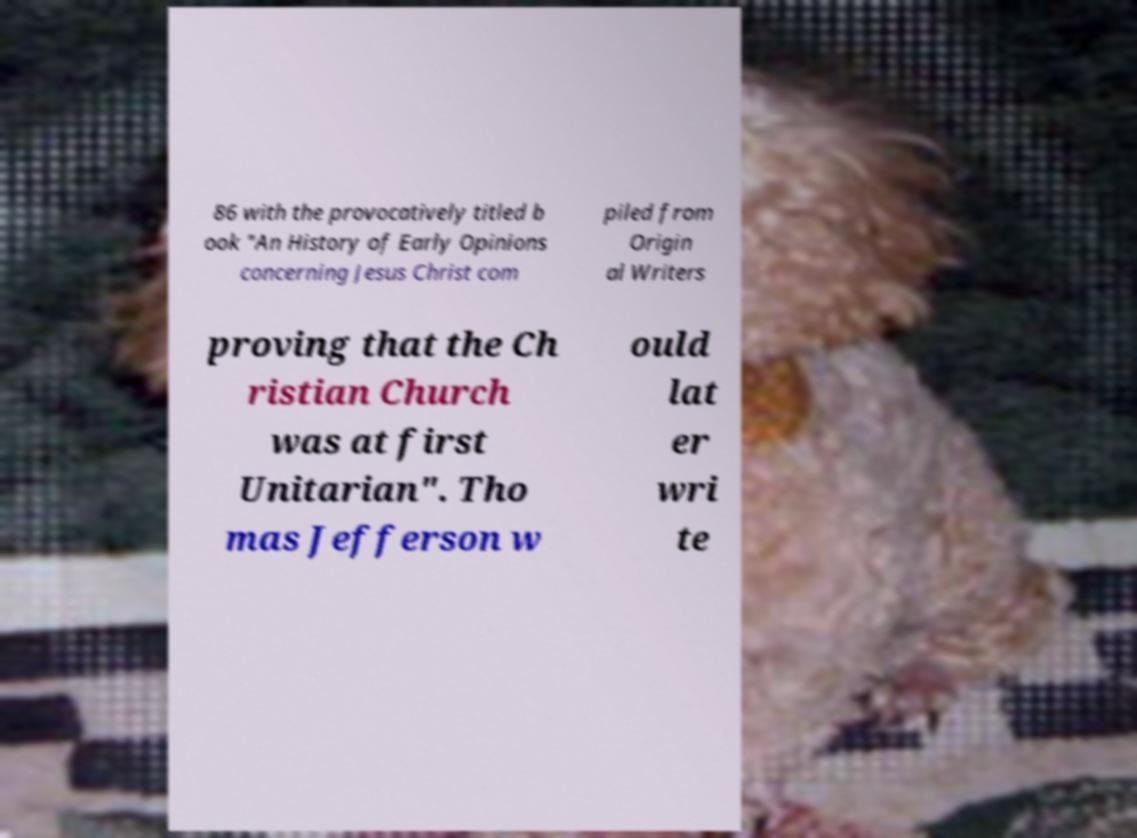Please read and relay the text visible in this image. What does it say? 86 with the provocatively titled b ook "An History of Early Opinions concerning Jesus Christ com piled from Origin al Writers proving that the Ch ristian Church was at first Unitarian". Tho mas Jefferson w ould lat er wri te 